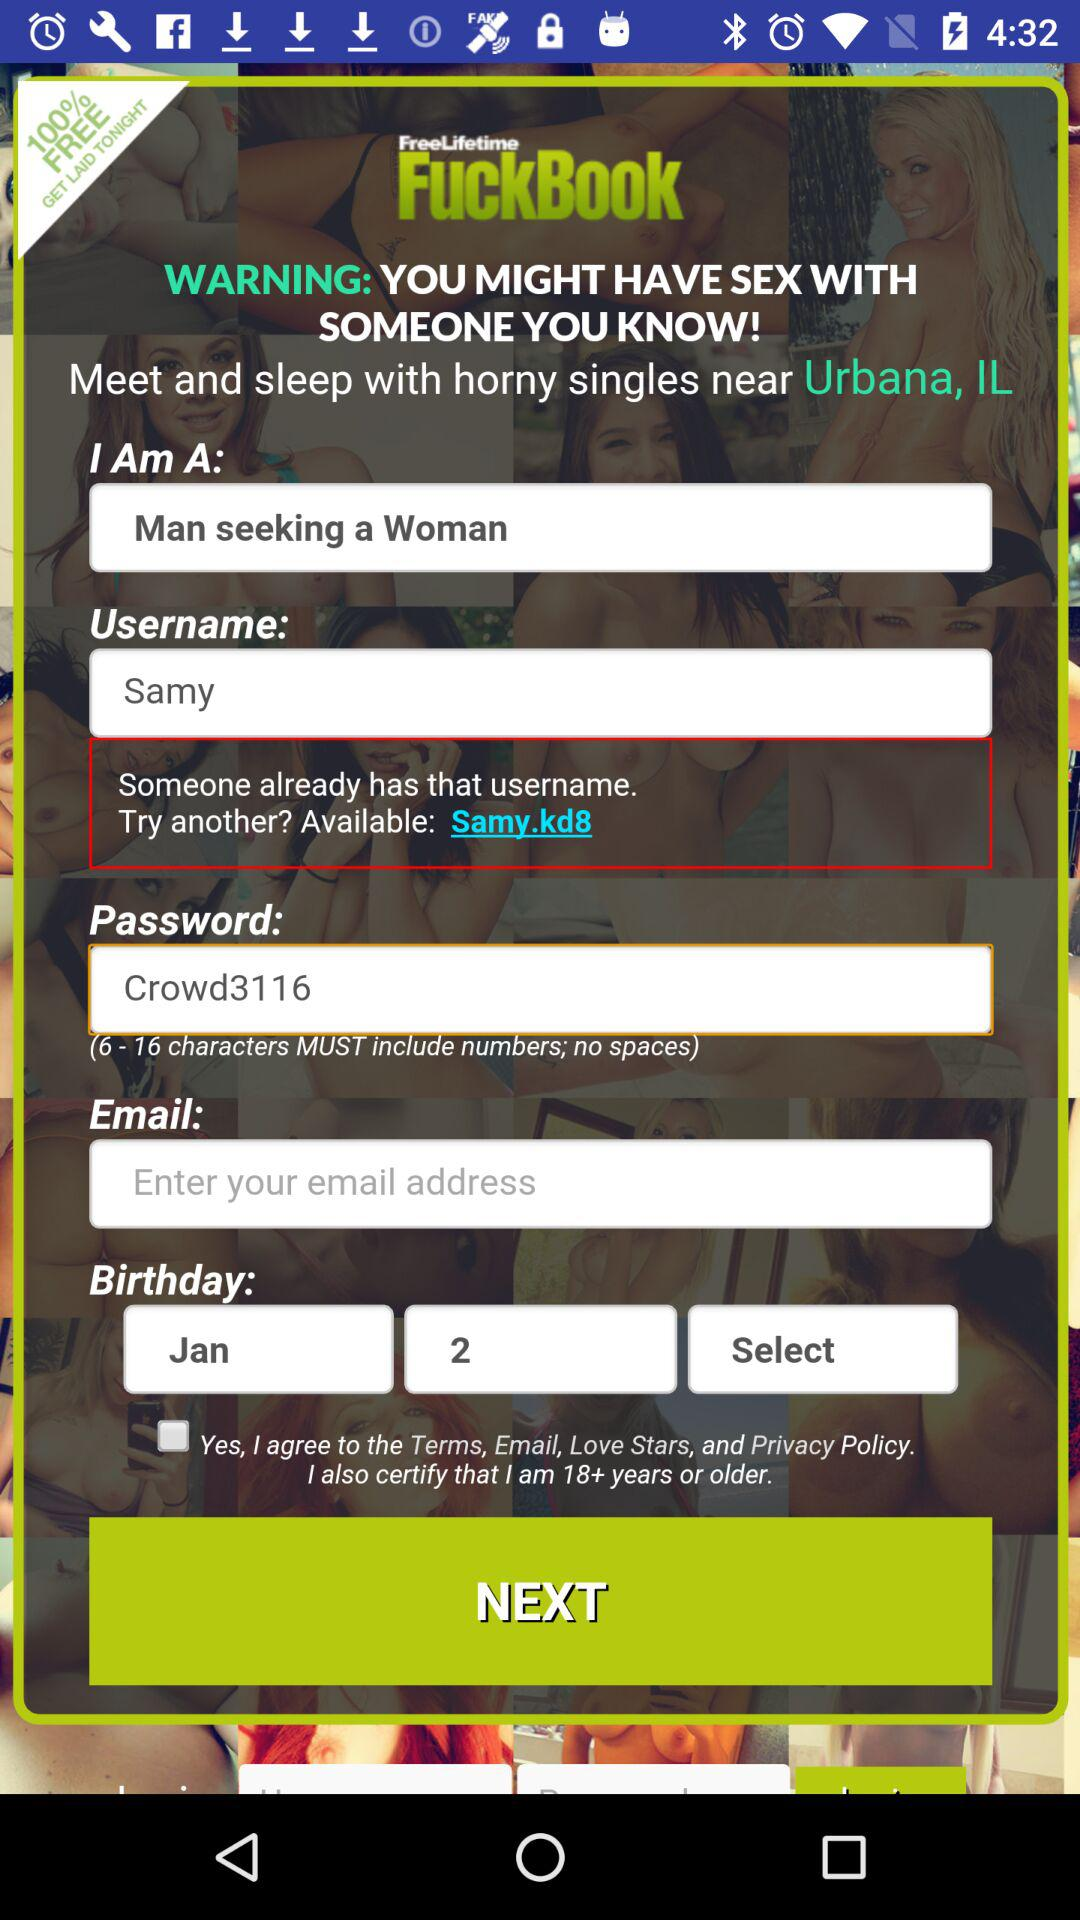How many characters must be included in the password? The password must include six to sixteen characters. 